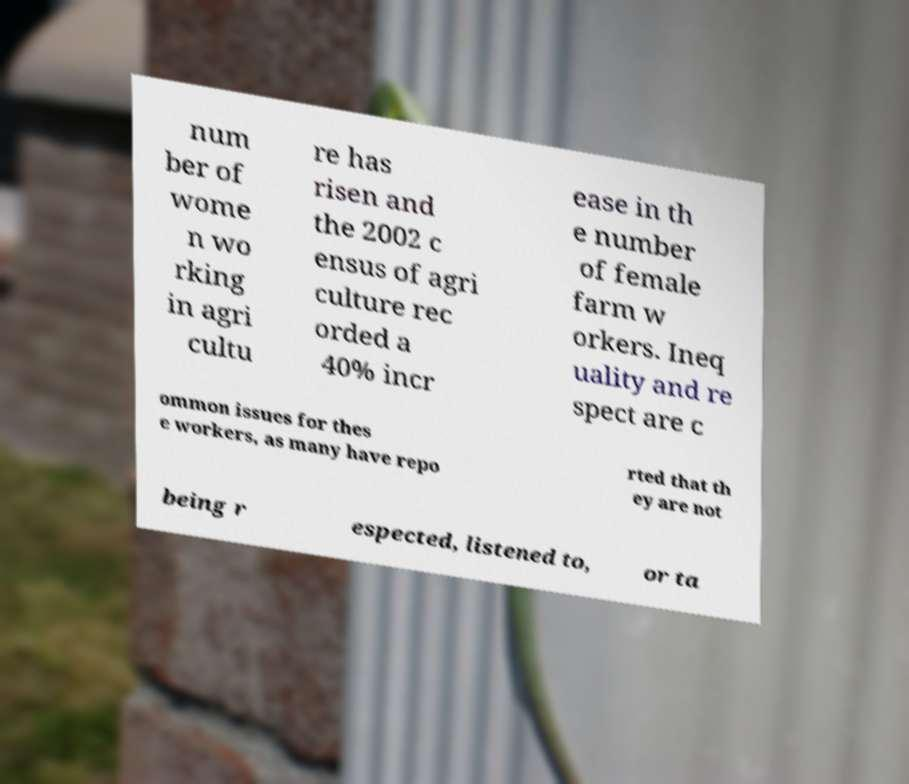Please read and relay the text visible in this image. What does it say? num ber of wome n wo rking in agri cultu re has risen and the 2002 c ensus of agri culture rec orded a 40% incr ease in th e number of female farm w orkers. Ineq uality and re spect are c ommon issues for thes e workers, as many have repo rted that th ey are not being r espected, listened to, or ta 